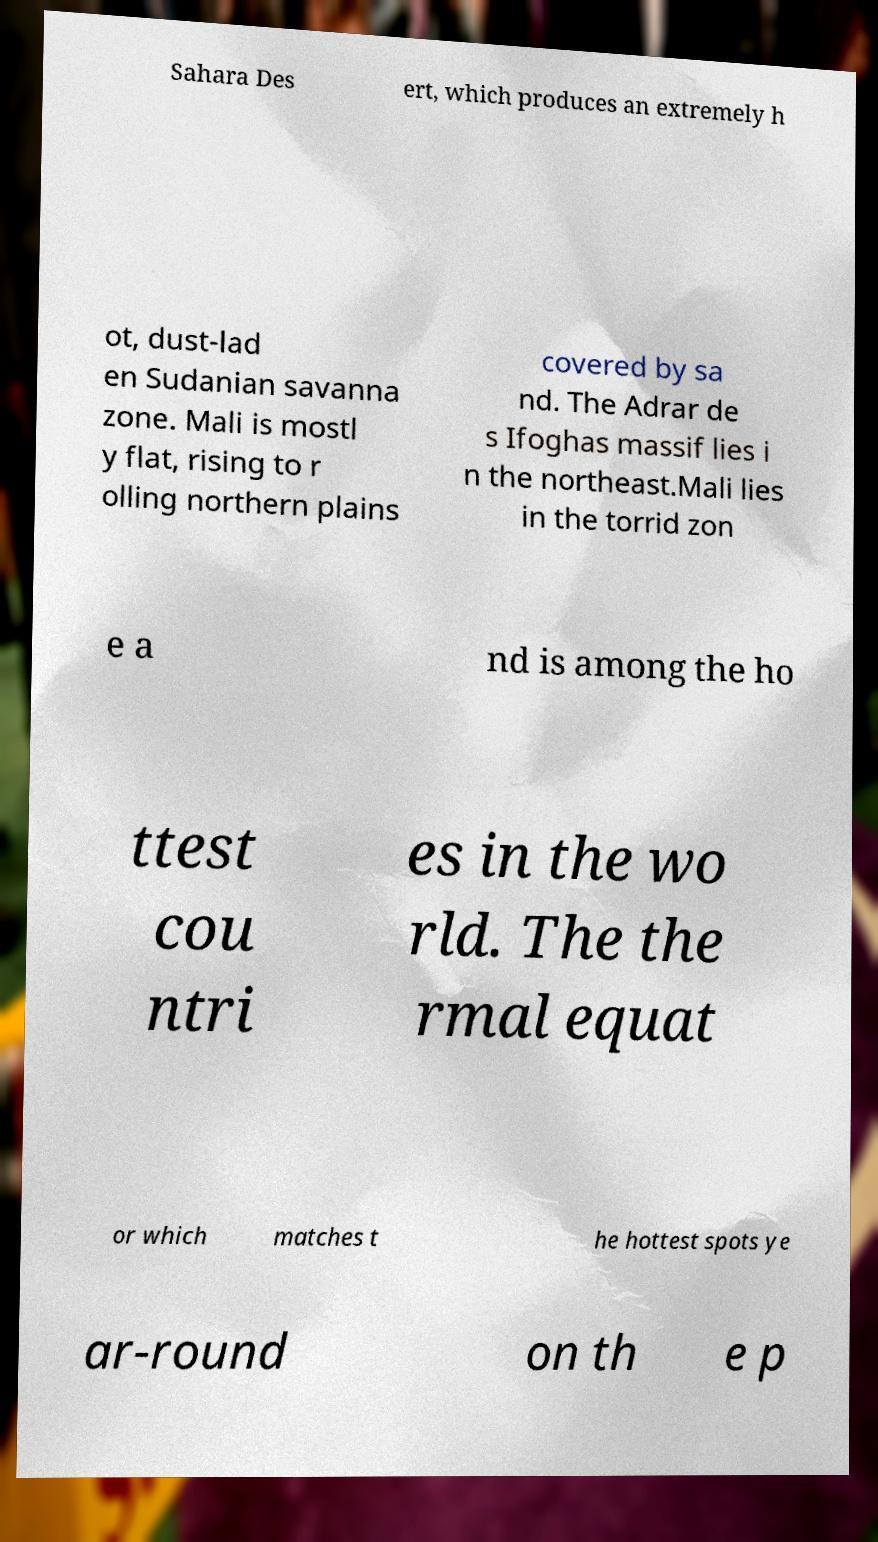For documentation purposes, I need the text within this image transcribed. Could you provide that? Sahara Des ert, which produces an extremely h ot, dust-lad en Sudanian savanna zone. Mali is mostl y flat, rising to r olling northern plains covered by sa nd. The Adrar de s Ifoghas massif lies i n the northeast.Mali lies in the torrid zon e a nd is among the ho ttest cou ntri es in the wo rld. The the rmal equat or which matches t he hottest spots ye ar-round on th e p 